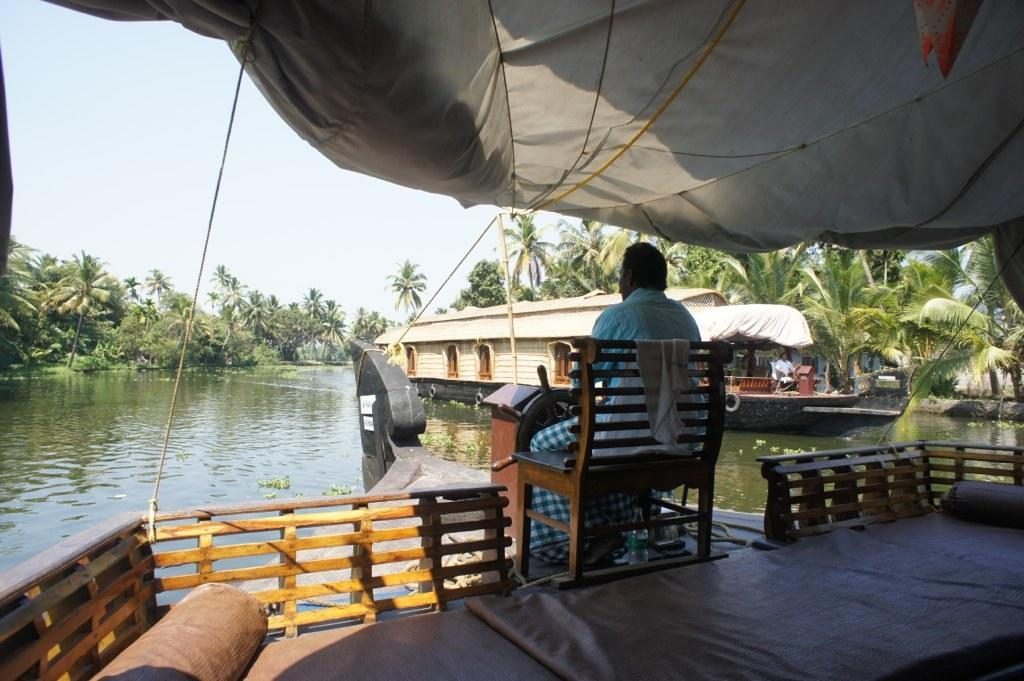What is the main subject of the image? The main subject of the image is a man. What is the man doing in the image? The man is sitting on a chair and riding a boat in the image. What can be seen in the background of the image? There is a boat, a river, and many trees visible in the background of the image. How much money does the secretary have in the image? There is no secretary present in the image, and therefore no amount of money can be determined. 